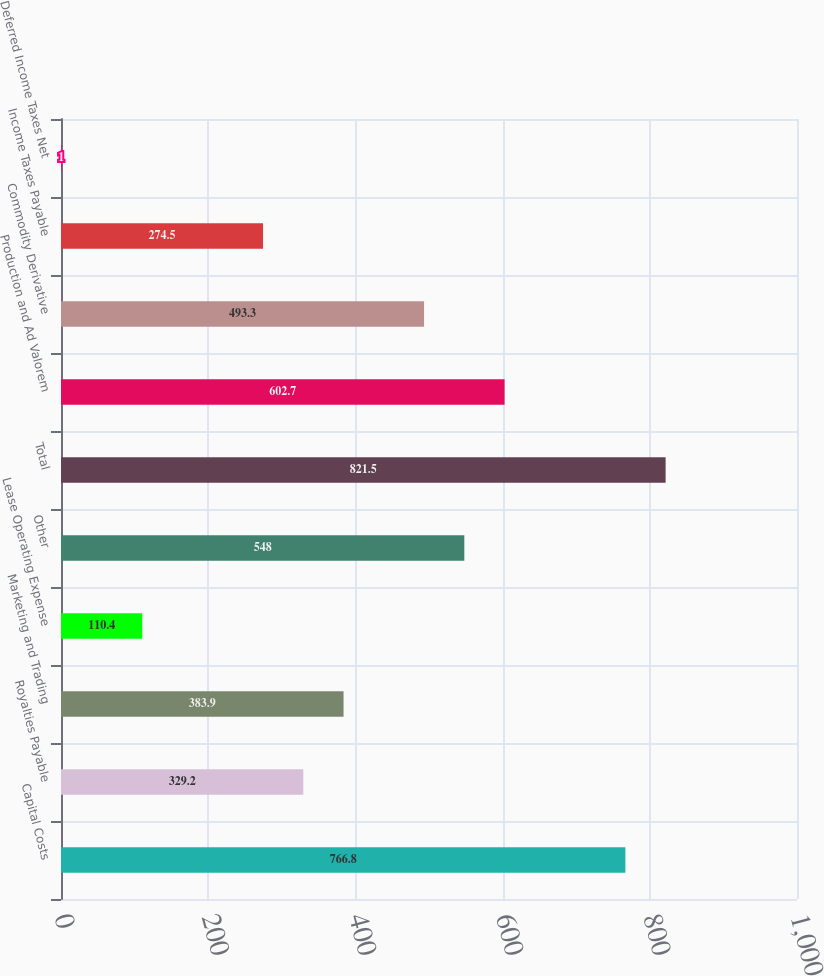Convert chart to OTSL. <chart><loc_0><loc_0><loc_500><loc_500><bar_chart><fcel>Capital Costs<fcel>Royalties Payable<fcel>Marketing and Trading<fcel>Lease Operating Expense<fcel>Other<fcel>Total<fcel>Production and Ad Valorem<fcel>Commodity Derivative<fcel>Income Taxes Payable<fcel>Deferred Income Taxes Net<nl><fcel>766.8<fcel>329.2<fcel>383.9<fcel>110.4<fcel>548<fcel>821.5<fcel>602.7<fcel>493.3<fcel>274.5<fcel>1<nl></chart> 